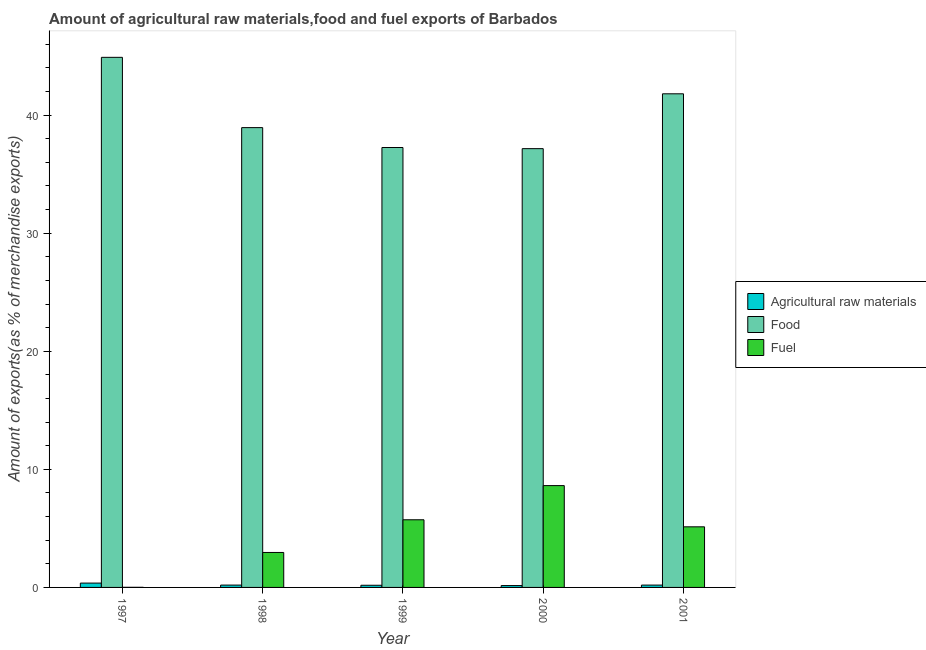How many groups of bars are there?
Your answer should be compact. 5. Are the number of bars per tick equal to the number of legend labels?
Make the answer very short. Yes. How many bars are there on the 4th tick from the right?
Make the answer very short. 3. What is the label of the 4th group of bars from the left?
Offer a very short reply. 2000. What is the percentage of fuel exports in 2001?
Offer a terse response. 5.13. Across all years, what is the maximum percentage of fuel exports?
Keep it short and to the point. 8.62. Across all years, what is the minimum percentage of food exports?
Give a very brief answer. 37.16. What is the total percentage of raw materials exports in the graph?
Your answer should be very brief. 1.1. What is the difference between the percentage of fuel exports in 1998 and that in 2001?
Offer a terse response. -2.17. What is the difference between the percentage of fuel exports in 1997 and the percentage of raw materials exports in 1998?
Provide a succinct answer. -2.95. What is the average percentage of raw materials exports per year?
Make the answer very short. 0.22. In how many years, is the percentage of fuel exports greater than 32 %?
Ensure brevity in your answer.  0. What is the ratio of the percentage of fuel exports in 1997 to that in 1999?
Give a very brief answer. 0. What is the difference between the highest and the second highest percentage of raw materials exports?
Ensure brevity in your answer.  0.17. What is the difference between the highest and the lowest percentage of fuel exports?
Your response must be concise. 8.62. In how many years, is the percentage of food exports greater than the average percentage of food exports taken over all years?
Provide a succinct answer. 2. Is the sum of the percentage of food exports in 1999 and 2000 greater than the maximum percentage of fuel exports across all years?
Your answer should be very brief. Yes. What does the 2nd bar from the left in 2000 represents?
Keep it short and to the point. Food. What does the 1st bar from the right in 2001 represents?
Your answer should be compact. Fuel. Are all the bars in the graph horizontal?
Give a very brief answer. No. Where does the legend appear in the graph?
Offer a very short reply. Center right. How many legend labels are there?
Give a very brief answer. 3. What is the title of the graph?
Provide a short and direct response. Amount of agricultural raw materials,food and fuel exports of Barbados. Does "Textiles and clothing" appear as one of the legend labels in the graph?
Keep it short and to the point. No. What is the label or title of the X-axis?
Ensure brevity in your answer.  Year. What is the label or title of the Y-axis?
Keep it short and to the point. Amount of exports(as % of merchandise exports). What is the Amount of exports(as % of merchandise exports) of Agricultural raw materials in 1997?
Your response must be concise. 0.37. What is the Amount of exports(as % of merchandise exports) in Food in 1997?
Offer a very short reply. 44.9. What is the Amount of exports(as % of merchandise exports) of Fuel in 1997?
Your response must be concise. 0.01. What is the Amount of exports(as % of merchandise exports) of Agricultural raw materials in 1998?
Ensure brevity in your answer.  0.2. What is the Amount of exports(as % of merchandise exports) of Food in 1998?
Provide a succinct answer. 38.94. What is the Amount of exports(as % of merchandise exports) in Fuel in 1998?
Ensure brevity in your answer.  2.96. What is the Amount of exports(as % of merchandise exports) in Agricultural raw materials in 1999?
Your response must be concise. 0.18. What is the Amount of exports(as % of merchandise exports) in Food in 1999?
Provide a succinct answer. 37.26. What is the Amount of exports(as % of merchandise exports) of Fuel in 1999?
Ensure brevity in your answer.  5.73. What is the Amount of exports(as % of merchandise exports) in Agricultural raw materials in 2000?
Provide a succinct answer. 0.16. What is the Amount of exports(as % of merchandise exports) of Food in 2000?
Offer a very short reply. 37.16. What is the Amount of exports(as % of merchandise exports) of Fuel in 2000?
Offer a very short reply. 8.62. What is the Amount of exports(as % of merchandise exports) in Agricultural raw materials in 2001?
Your answer should be very brief. 0.2. What is the Amount of exports(as % of merchandise exports) of Food in 2001?
Offer a very short reply. 41.81. What is the Amount of exports(as % of merchandise exports) in Fuel in 2001?
Keep it short and to the point. 5.13. Across all years, what is the maximum Amount of exports(as % of merchandise exports) of Agricultural raw materials?
Provide a short and direct response. 0.37. Across all years, what is the maximum Amount of exports(as % of merchandise exports) in Food?
Give a very brief answer. 44.9. Across all years, what is the maximum Amount of exports(as % of merchandise exports) in Fuel?
Ensure brevity in your answer.  8.62. Across all years, what is the minimum Amount of exports(as % of merchandise exports) in Agricultural raw materials?
Your response must be concise. 0.16. Across all years, what is the minimum Amount of exports(as % of merchandise exports) in Food?
Provide a short and direct response. 37.16. Across all years, what is the minimum Amount of exports(as % of merchandise exports) in Fuel?
Your answer should be compact. 0.01. What is the total Amount of exports(as % of merchandise exports) of Agricultural raw materials in the graph?
Offer a terse response. 1.1. What is the total Amount of exports(as % of merchandise exports) of Food in the graph?
Make the answer very short. 200.07. What is the total Amount of exports(as % of merchandise exports) of Fuel in the graph?
Your answer should be very brief. 22.46. What is the difference between the Amount of exports(as % of merchandise exports) in Agricultural raw materials in 1997 and that in 1998?
Make the answer very short. 0.17. What is the difference between the Amount of exports(as % of merchandise exports) in Food in 1997 and that in 1998?
Ensure brevity in your answer.  5.95. What is the difference between the Amount of exports(as % of merchandise exports) in Fuel in 1997 and that in 1998?
Keep it short and to the point. -2.95. What is the difference between the Amount of exports(as % of merchandise exports) in Agricultural raw materials in 1997 and that in 1999?
Offer a terse response. 0.18. What is the difference between the Amount of exports(as % of merchandise exports) in Food in 1997 and that in 1999?
Ensure brevity in your answer.  7.64. What is the difference between the Amount of exports(as % of merchandise exports) in Fuel in 1997 and that in 1999?
Provide a succinct answer. -5.72. What is the difference between the Amount of exports(as % of merchandise exports) in Agricultural raw materials in 1997 and that in 2000?
Your response must be concise. 0.21. What is the difference between the Amount of exports(as % of merchandise exports) in Food in 1997 and that in 2000?
Provide a succinct answer. 7.73. What is the difference between the Amount of exports(as % of merchandise exports) of Fuel in 1997 and that in 2000?
Offer a terse response. -8.62. What is the difference between the Amount of exports(as % of merchandise exports) in Agricultural raw materials in 1997 and that in 2001?
Your answer should be very brief. 0.17. What is the difference between the Amount of exports(as % of merchandise exports) of Food in 1997 and that in 2001?
Make the answer very short. 3.09. What is the difference between the Amount of exports(as % of merchandise exports) in Fuel in 1997 and that in 2001?
Offer a terse response. -5.12. What is the difference between the Amount of exports(as % of merchandise exports) of Agricultural raw materials in 1998 and that in 1999?
Your answer should be compact. 0.02. What is the difference between the Amount of exports(as % of merchandise exports) of Food in 1998 and that in 1999?
Your answer should be very brief. 1.68. What is the difference between the Amount of exports(as % of merchandise exports) in Fuel in 1998 and that in 1999?
Give a very brief answer. -2.77. What is the difference between the Amount of exports(as % of merchandise exports) of Agricultural raw materials in 1998 and that in 2000?
Provide a short and direct response. 0.04. What is the difference between the Amount of exports(as % of merchandise exports) of Food in 1998 and that in 2000?
Ensure brevity in your answer.  1.78. What is the difference between the Amount of exports(as % of merchandise exports) in Fuel in 1998 and that in 2000?
Ensure brevity in your answer.  -5.66. What is the difference between the Amount of exports(as % of merchandise exports) in Agricultural raw materials in 1998 and that in 2001?
Your answer should be compact. 0. What is the difference between the Amount of exports(as % of merchandise exports) in Food in 1998 and that in 2001?
Provide a succinct answer. -2.86. What is the difference between the Amount of exports(as % of merchandise exports) of Fuel in 1998 and that in 2001?
Keep it short and to the point. -2.17. What is the difference between the Amount of exports(as % of merchandise exports) in Agricultural raw materials in 1999 and that in 2000?
Keep it short and to the point. 0.03. What is the difference between the Amount of exports(as % of merchandise exports) in Food in 1999 and that in 2000?
Keep it short and to the point. 0.1. What is the difference between the Amount of exports(as % of merchandise exports) in Fuel in 1999 and that in 2000?
Ensure brevity in your answer.  -2.89. What is the difference between the Amount of exports(as % of merchandise exports) of Agricultural raw materials in 1999 and that in 2001?
Provide a succinct answer. -0.01. What is the difference between the Amount of exports(as % of merchandise exports) of Food in 1999 and that in 2001?
Ensure brevity in your answer.  -4.55. What is the difference between the Amount of exports(as % of merchandise exports) in Fuel in 1999 and that in 2001?
Provide a succinct answer. 0.6. What is the difference between the Amount of exports(as % of merchandise exports) in Agricultural raw materials in 2000 and that in 2001?
Make the answer very short. -0.04. What is the difference between the Amount of exports(as % of merchandise exports) in Food in 2000 and that in 2001?
Provide a short and direct response. -4.65. What is the difference between the Amount of exports(as % of merchandise exports) of Fuel in 2000 and that in 2001?
Give a very brief answer. 3.49. What is the difference between the Amount of exports(as % of merchandise exports) of Agricultural raw materials in 1997 and the Amount of exports(as % of merchandise exports) of Food in 1998?
Offer a very short reply. -38.58. What is the difference between the Amount of exports(as % of merchandise exports) of Agricultural raw materials in 1997 and the Amount of exports(as % of merchandise exports) of Fuel in 1998?
Give a very brief answer. -2.59. What is the difference between the Amount of exports(as % of merchandise exports) in Food in 1997 and the Amount of exports(as % of merchandise exports) in Fuel in 1998?
Offer a very short reply. 41.94. What is the difference between the Amount of exports(as % of merchandise exports) in Agricultural raw materials in 1997 and the Amount of exports(as % of merchandise exports) in Food in 1999?
Offer a terse response. -36.89. What is the difference between the Amount of exports(as % of merchandise exports) of Agricultural raw materials in 1997 and the Amount of exports(as % of merchandise exports) of Fuel in 1999?
Provide a short and direct response. -5.36. What is the difference between the Amount of exports(as % of merchandise exports) in Food in 1997 and the Amount of exports(as % of merchandise exports) in Fuel in 1999?
Your response must be concise. 39.17. What is the difference between the Amount of exports(as % of merchandise exports) of Agricultural raw materials in 1997 and the Amount of exports(as % of merchandise exports) of Food in 2000?
Your response must be concise. -36.8. What is the difference between the Amount of exports(as % of merchandise exports) of Agricultural raw materials in 1997 and the Amount of exports(as % of merchandise exports) of Fuel in 2000?
Ensure brevity in your answer.  -8.26. What is the difference between the Amount of exports(as % of merchandise exports) in Food in 1997 and the Amount of exports(as % of merchandise exports) in Fuel in 2000?
Give a very brief answer. 36.27. What is the difference between the Amount of exports(as % of merchandise exports) of Agricultural raw materials in 1997 and the Amount of exports(as % of merchandise exports) of Food in 2001?
Provide a succinct answer. -41.44. What is the difference between the Amount of exports(as % of merchandise exports) in Agricultural raw materials in 1997 and the Amount of exports(as % of merchandise exports) in Fuel in 2001?
Your answer should be very brief. -4.77. What is the difference between the Amount of exports(as % of merchandise exports) of Food in 1997 and the Amount of exports(as % of merchandise exports) of Fuel in 2001?
Keep it short and to the point. 39.76. What is the difference between the Amount of exports(as % of merchandise exports) in Agricultural raw materials in 1998 and the Amount of exports(as % of merchandise exports) in Food in 1999?
Ensure brevity in your answer.  -37.06. What is the difference between the Amount of exports(as % of merchandise exports) of Agricultural raw materials in 1998 and the Amount of exports(as % of merchandise exports) of Fuel in 1999?
Offer a terse response. -5.53. What is the difference between the Amount of exports(as % of merchandise exports) of Food in 1998 and the Amount of exports(as % of merchandise exports) of Fuel in 1999?
Give a very brief answer. 33.21. What is the difference between the Amount of exports(as % of merchandise exports) of Agricultural raw materials in 1998 and the Amount of exports(as % of merchandise exports) of Food in 2000?
Ensure brevity in your answer.  -36.96. What is the difference between the Amount of exports(as % of merchandise exports) in Agricultural raw materials in 1998 and the Amount of exports(as % of merchandise exports) in Fuel in 2000?
Keep it short and to the point. -8.43. What is the difference between the Amount of exports(as % of merchandise exports) of Food in 1998 and the Amount of exports(as % of merchandise exports) of Fuel in 2000?
Offer a very short reply. 30.32. What is the difference between the Amount of exports(as % of merchandise exports) in Agricultural raw materials in 1998 and the Amount of exports(as % of merchandise exports) in Food in 2001?
Your answer should be compact. -41.61. What is the difference between the Amount of exports(as % of merchandise exports) in Agricultural raw materials in 1998 and the Amount of exports(as % of merchandise exports) in Fuel in 2001?
Make the answer very short. -4.93. What is the difference between the Amount of exports(as % of merchandise exports) of Food in 1998 and the Amount of exports(as % of merchandise exports) of Fuel in 2001?
Your response must be concise. 33.81. What is the difference between the Amount of exports(as % of merchandise exports) of Agricultural raw materials in 1999 and the Amount of exports(as % of merchandise exports) of Food in 2000?
Your response must be concise. -36.98. What is the difference between the Amount of exports(as % of merchandise exports) in Agricultural raw materials in 1999 and the Amount of exports(as % of merchandise exports) in Fuel in 2000?
Give a very brief answer. -8.44. What is the difference between the Amount of exports(as % of merchandise exports) of Food in 1999 and the Amount of exports(as % of merchandise exports) of Fuel in 2000?
Provide a short and direct response. 28.64. What is the difference between the Amount of exports(as % of merchandise exports) of Agricultural raw materials in 1999 and the Amount of exports(as % of merchandise exports) of Food in 2001?
Offer a very short reply. -41.63. What is the difference between the Amount of exports(as % of merchandise exports) in Agricultural raw materials in 1999 and the Amount of exports(as % of merchandise exports) in Fuel in 2001?
Your response must be concise. -4.95. What is the difference between the Amount of exports(as % of merchandise exports) of Food in 1999 and the Amount of exports(as % of merchandise exports) of Fuel in 2001?
Your response must be concise. 32.13. What is the difference between the Amount of exports(as % of merchandise exports) in Agricultural raw materials in 2000 and the Amount of exports(as % of merchandise exports) in Food in 2001?
Your response must be concise. -41.65. What is the difference between the Amount of exports(as % of merchandise exports) in Agricultural raw materials in 2000 and the Amount of exports(as % of merchandise exports) in Fuel in 2001?
Keep it short and to the point. -4.98. What is the difference between the Amount of exports(as % of merchandise exports) in Food in 2000 and the Amount of exports(as % of merchandise exports) in Fuel in 2001?
Provide a succinct answer. 32.03. What is the average Amount of exports(as % of merchandise exports) of Agricultural raw materials per year?
Ensure brevity in your answer.  0.22. What is the average Amount of exports(as % of merchandise exports) in Food per year?
Ensure brevity in your answer.  40.01. What is the average Amount of exports(as % of merchandise exports) in Fuel per year?
Give a very brief answer. 4.49. In the year 1997, what is the difference between the Amount of exports(as % of merchandise exports) of Agricultural raw materials and Amount of exports(as % of merchandise exports) of Food?
Your answer should be very brief. -44.53. In the year 1997, what is the difference between the Amount of exports(as % of merchandise exports) of Agricultural raw materials and Amount of exports(as % of merchandise exports) of Fuel?
Offer a very short reply. 0.36. In the year 1997, what is the difference between the Amount of exports(as % of merchandise exports) of Food and Amount of exports(as % of merchandise exports) of Fuel?
Provide a succinct answer. 44.89. In the year 1998, what is the difference between the Amount of exports(as % of merchandise exports) in Agricultural raw materials and Amount of exports(as % of merchandise exports) in Food?
Provide a succinct answer. -38.75. In the year 1998, what is the difference between the Amount of exports(as % of merchandise exports) in Agricultural raw materials and Amount of exports(as % of merchandise exports) in Fuel?
Your answer should be very brief. -2.76. In the year 1998, what is the difference between the Amount of exports(as % of merchandise exports) in Food and Amount of exports(as % of merchandise exports) in Fuel?
Ensure brevity in your answer.  35.98. In the year 1999, what is the difference between the Amount of exports(as % of merchandise exports) of Agricultural raw materials and Amount of exports(as % of merchandise exports) of Food?
Offer a very short reply. -37.08. In the year 1999, what is the difference between the Amount of exports(as % of merchandise exports) of Agricultural raw materials and Amount of exports(as % of merchandise exports) of Fuel?
Your answer should be compact. -5.55. In the year 1999, what is the difference between the Amount of exports(as % of merchandise exports) of Food and Amount of exports(as % of merchandise exports) of Fuel?
Offer a very short reply. 31.53. In the year 2000, what is the difference between the Amount of exports(as % of merchandise exports) in Agricultural raw materials and Amount of exports(as % of merchandise exports) in Food?
Your response must be concise. -37.01. In the year 2000, what is the difference between the Amount of exports(as % of merchandise exports) in Agricultural raw materials and Amount of exports(as % of merchandise exports) in Fuel?
Your response must be concise. -8.47. In the year 2000, what is the difference between the Amount of exports(as % of merchandise exports) in Food and Amount of exports(as % of merchandise exports) in Fuel?
Offer a terse response. 28.54. In the year 2001, what is the difference between the Amount of exports(as % of merchandise exports) of Agricultural raw materials and Amount of exports(as % of merchandise exports) of Food?
Give a very brief answer. -41.61. In the year 2001, what is the difference between the Amount of exports(as % of merchandise exports) of Agricultural raw materials and Amount of exports(as % of merchandise exports) of Fuel?
Provide a short and direct response. -4.94. In the year 2001, what is the difference between the Amount of exports(as % of merchandise exports) of Food and Amount of exports(as % of merchandise exports) of Fuel?
Provide a succinct answer. 36.68. What is the ratio of the Amount of exports(as % of merchandise exports) in Agricultural raw materials in 1997 to that in 1998?
Make the answer very short. 1.85. What is the ratio of the Amount of exports(as % of merchandise exports) of Food in 1997 to that in 1998?
Your answer should be very brief. 1.15. What is the ratio of the Amount of exports(as % of merchandise exports) of Fuel in 1997 to that in 1998?
Give a very brief answer. 0. What is the ratio of the Amount of exports(as % of merchandise exports) in Agricultural raw materials in 1997 to that in 1999?
Make the answer very short. 2.01. What is the ratio of the Amount of exports(as % of merchandise exports) of Food in 1997 to that in 1999?
Your answer should be very brief. 1.21. What is the ratio of the Amount of exports(as % of merchandise exports) in Fuel in 1997 to that in 1999?
Your response must be concise. 0. What is the ratio of the Amount of exports(as % of merchandise exports) in Agricultural raw materials in 1997 to that in 2000?
Provide a short and direct response. 2.33. What is the ratio of the Amount of exports(as % of merchandise exports) of Food in 1997 to that in 2000?
Ensure brevity in your answer.  1.21. What is the ratio of the Amount of exports(as % of merchandise exports) of Agricultural raw materials in 1997 to that in 2001?
Your answer should be compact. 1.86. What is the ratio of the Amount of exports(as % of merchandise exports) in Food in 1997 to that in 2001?
Keep it short and to the point. 1.07. What is the ratio of the Amount of exports(as % of merchandise exports) of Fuel in 1997 to that in 2001?
Offer a very short reply. 0. What is the ratio of the Amount of exports(as % of merchandise exports) in Agricultural raw materials in 1998 to that in 1999?
Provide a short and direct response. 1.08. What is the ratio of the Amount of exports(as % of merchandise exports) in Food in 1998 to that in 1999?
Your response must be concise. 1.05. What is the ratio of the Amount of exports(as % of merchandise exports) in Fuel in 1998 to that in 1999?
Ensure brevity in your answer.  0.52. What is the ratio of the Amount of exports(as % of merchandise exports) in Agricultural raw materials in 1998 to that in 2000?
Offer a very short reply. 1.26. What is the ratio of the Amount of exports(as % of merchandise exports) of Food in 1998 to that in 2000?
Your answer should be very brief. 1.05. What is the ratio of the Amount of exports(as % of merchandise exports) in Fuel in 1998 to that in 2000?
Your answer should be compact. 0.34. What is the ratio of the Amount of exports(as % of merchandise exports) in Agricultural raw materials in 1998 to that in 2001?
Your answer should be compact. 1. What is the ratio of the Amount of exports(as % of merchandise exports) of Food in 1998 to that in 2001?
Provide a succinct answer. 0.93. What is the ratio of the Amount of exports(as % of merchandise exports) of Fuel in 1998 to that in 2001?
Provide a succinct answer. 0.58. What is the ratio of the Amount of exports(as % of merchandise exports) in Agricultural raw materials in 1999 to that in 2000?
Your response must be concise. 1.16. What is the ratio of the Amount of exports(as % of merchandise exports) in Food in 1999 to that in 2000?
Your answer should be very brief. 1. What is the ratio of the Amount of exports(as % of merchandise exports) of Fuel in 1999 to that in 2000?
Offer a terse response. 0.66. What is the ratio of the Amount of exports(as % of merchandise exports) in Agricultural raw materials in 1999 to that in 2001?
Offer a terse response. 0.93. What is the ratio of the Amount of exports(as % of merchandise exports) in Food in 1999 to that in 2001?
Offer a very short reply. 0.89. What is the ratio of the Amount of exports(as % of merchandise exports) of Fuel in 1999 to that in 2001?
Your answer should be compact. 1.12. What is the ratio of the Amount of exports(as % of merchandise exports) of Agricultural raw materials in 2000 to that in 2001?
Offer a very short reply. 0.8. What is the ratio of the Amount of exports(as % of merchandise exports) in Fuel in 2000 to that in 2001?
Your answer should be compact. 1.68. What is the difference between the highest and the second highest Amount of exports(as % of merchandise exports) in Agricultural raw materials?
Provide a succinct answer. 0.17. What is the difference between the highest and the second highest Amount of exports(as % of merchandise exports) in Food?
Make the answer very short. 3.09. What is the difference between the highest and the second highest Amount of exports(as % of merchandise exports) of Fuel?
Offer a terse response. 2.89. What is the difference between the highest and the lowest Amount of exports(as % of merchandise exports) of Agricultural raw materials?
Give a very brief answer. 0.21. What is the difference between the highest and the lowest Amount of exports(as % of merchandise exports) in Food?
Offer a very short reply. 7.73. What is the difference between the highest and the lowest Amount of exports(as % of merchandise exports) in Fuel?
Keep it short and to the point. 8.62. 